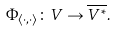Convert formula to latex. <formula><loc_0><loc_0><loc_500><loc_500>\Phi _ { \langle \cdot , \cdot \rangle } \colon V \to { \overline { { V ^ { * } } } } .</formula> 